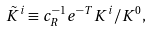<formula> <loc_0><loc_0><loc_500><loc_500>\tilde { K } ^ { i } \equiv c _ { R } ^ { - 1 } { e } ^ { - T } K ^ { i } / K ^ { 0 } ,</formula> 